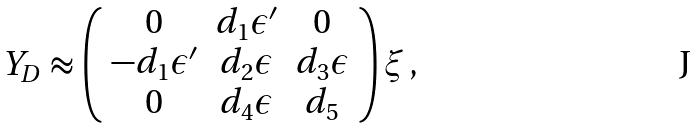Convert formula to latex. <formula><loc_0><loc_0><loc_500><loc_500>Y _ { D } \approx \left ( \begin{array} { c c c } 0 & d _ { 1 } \epsilon ^ { \prime } & 0 \\ - d _ { 1 } \epsilon ^ { \prime } & d _ { 2 } \epsilon & d _ { 3 } \epsilon \\ 0 & d _ { 4 } \epsilon & d _ { 5 } \end{array} \right ) \xi \, ,</formula> 